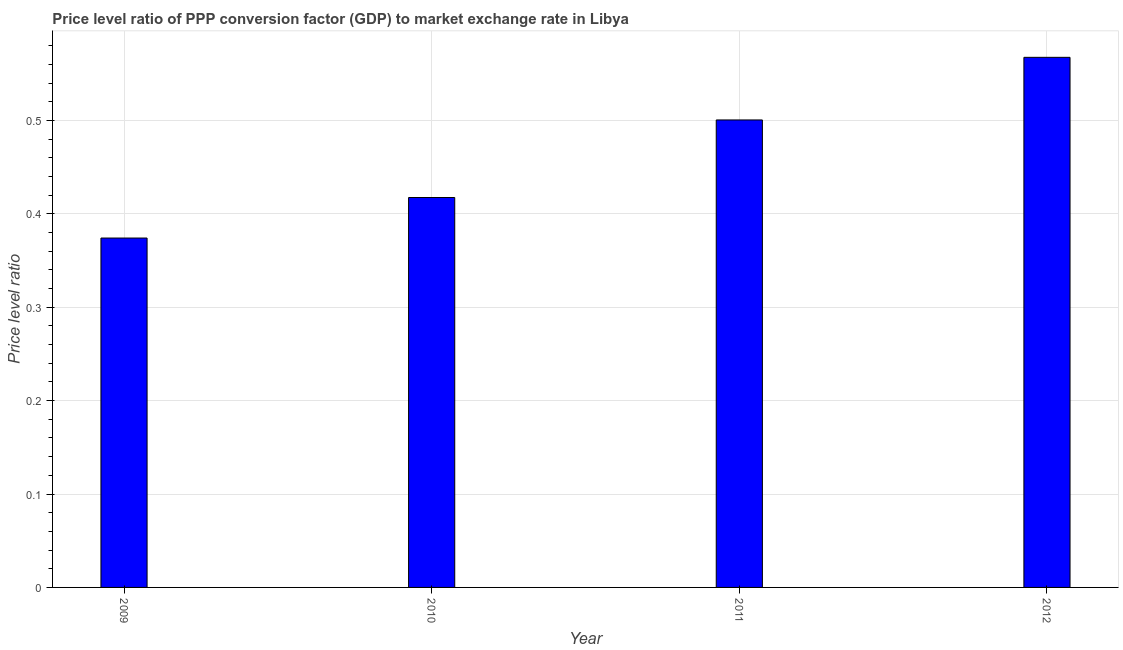Does the graph contain any zero values?
Make the answer very short. No. What is the title of the graph?
Ensure brevity in your answer.  Price level ratio of PPP conversion factor (GDP) to market exchange rate in Libya. What is the label or title of the X-axis?
Offer a terse response. Year. What is the label or title of the Y-axis?
Ensure brevity in your answer.  Price level ratio. What is the price level ratio in 2011?
Your response must be concise. 0.5. Across all years, what is the maximum price level ratio?
Your answer should be very brief. 0.57. Across all years, what is the minimum price level ratio?
Provide a succinct answer. 0.37. In which year was the price level ratio maximum?
Provide a succinct answer. 2012. What is the sum of the price level ratio?
Offer a very short reply. 1.86. What is the difference between the price level ratio in 2009 and 2011?
Provide a succinct answer. -0.13. What is the average price level ratio per year?
Keep it short and to the point. 0.47. What is the median price level ratio?
Provide a succinct answer. 0.46. Do a majority of the years between 2010 and 2012 (inclusive) have price level ratio greater than 0.1 ?
Your answer should be compact. Yes. What is the ratio of the price level ratio in 2010 to that in 2012?
Give a very brief answer. 0.74. Is the difference between the price level ratio in 2009 and 2012 greater than the difference between any two years?
Your response must be concise. Yes. What is the difference between the highest and the second highest price level ratio?
Provide a succinct answer. 0.07. What is the difference between the highest and the lowest price level ratio?
Ensure brevity in your answer.  0.19. How many bars are there?
Provide a short and direct response. 4. How many years are there in the graph?
Ensure brevity in your answer.  4. What is the difference between two consecutive major ticks on the Y-axis?
Keep it short and to the point. 0.1. What is the Price level ratio of 2009?
Make the answer very short. 0.37. What is the Price level ratio of 2010?
Your answer should be compact. 0.42. What is the Price level ratio in 2011?
Provide a short and direct response. 0.5. What is the Price level ratio of 2012?
Provide a short and direct response. 0.57. What is the difference between the Price level ratio in 2009 and 2010?
Provide a short and direct response. -0.04. What is the difference between the Price level ratio in 2009 and 2011?
Provide a succinct answer. -0.13. What is the difference between the Price level ratio in 2009 and 2012?
Give a very brief answer. -0.19. What is the difference between the Price level ratio in 2010 and 2011?
Make the answer very short. -0.08. What is the difference between the Price level ratio in 2010 and 2012?
Your answer should be very brief. -0.15. What is the difference between the Price level ratio in 2011 and 2012?
Keep it short and to the point. -0.07. What is the ratio of the Price level ratio in 2009 to that in 2010?
Your answer should be very brief. 0.9. What is the ratio of the Price level ratio in 2009 to that in 2011?
Your answer should be very brief. 0.75. What is the ratio of the Price level ratio in 2009 to that in 2012?
Provide a short and direct response. 0.66. What is the ratio of the Price level ratio in 2010 to that in 2011?
Your answer should be very brief. 0.83. What is the ratio of the Price level ratio in 2010 to that in 2012?
Your response must be concise. 0.74. What is the ratio of the Price level ratio in 2011 to that in 2012?
Your answer should be very brief. 0.88. 